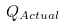Convert formula to latex. <formula><loc_0><loc_0><loc_500><loc_500>Q _ { A c t u a l } \,</formula> 